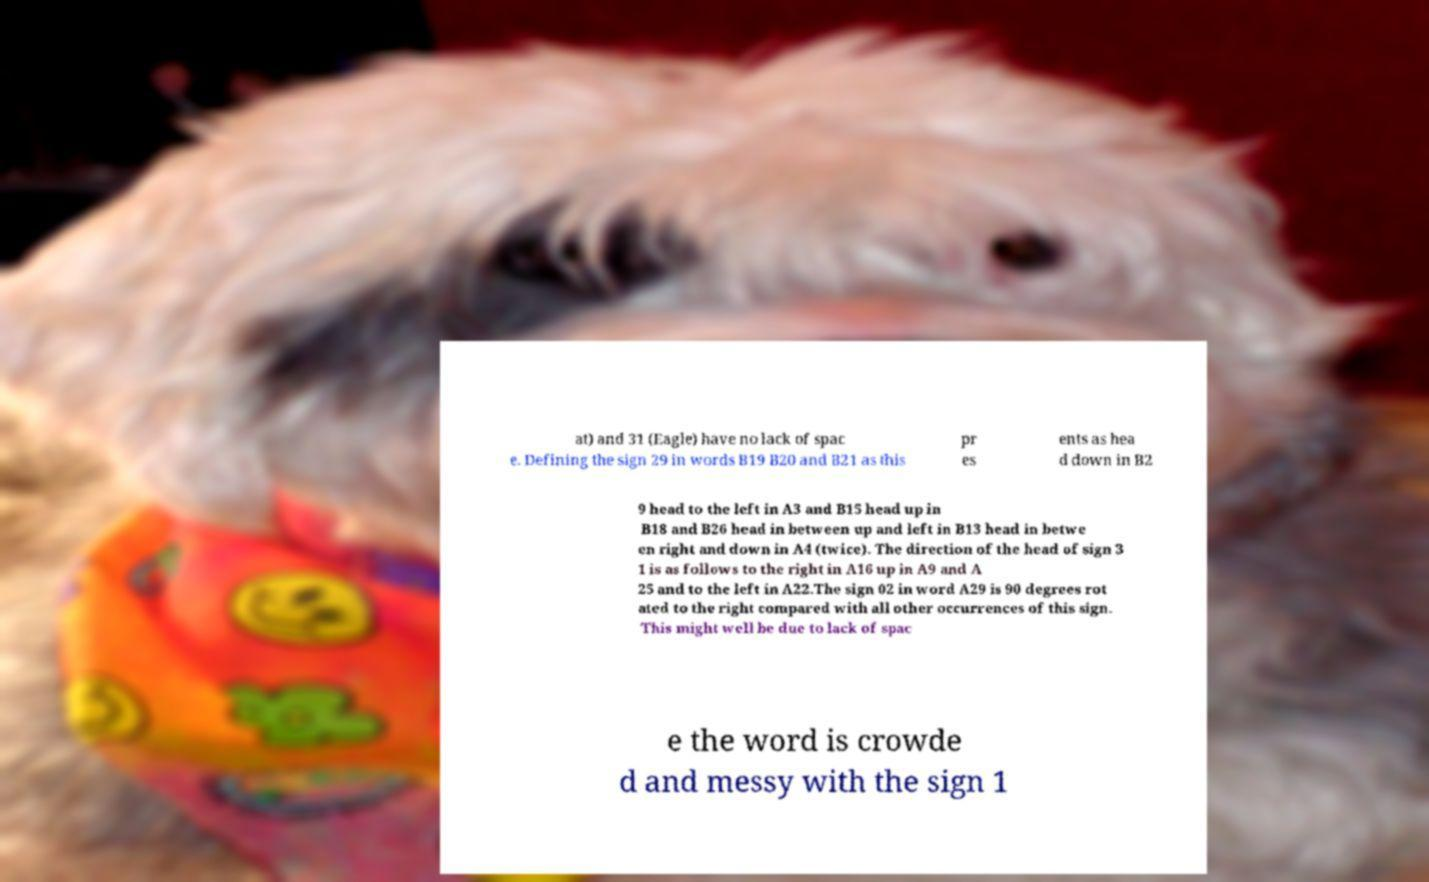Please read and relay the text visible in this image. What does it say? at) and 31 (Eagle) have no lack of spac e. Defining the sign 29 in words B19 B20 and B21 as this pr es ents as hea d down in B2 9 head to the left in A3 and B15 head up in B18 and B26 head in between up and left in B13 head in betwe en right and down in A4 (twice). The direction of the head of sign 3 1 is as follows to the right in A16 up in A9 and A 25 and to the left in A22.The sign 02 in word A29 is 90 degrees rot ated to the right compared with all other occurrences of this sign. This might well be due to lack of spac e the word is crowde d and messy with the sign 1 